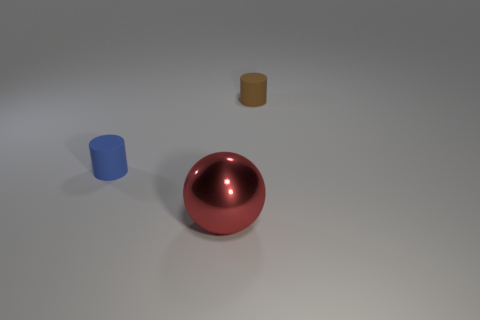Is there anything else that is the same size as the shiny ball?
Provide a short and direct response. No. Does the brown rubber cylinder have the same size as the metal sphere?
Make the answer very short. No. Are the tiny blue object that is behind the big metallic sphere and the cylinder right of the red shiny thing made of the same material?
Your response must be concise. Yes. Is there another matte thing of the same shape as the tiny brown matte thing?
Keep it short and to the point. Yes. What number of objects are big shiny balls in front of the brown matte cylinder or small blue rubber objects?
Give a very brief answer. 2. Are there more objects that are behind the big red metallic sphere than brown rubber things that are left of the tiny brown cylinder?
Your response must be concise. Yes. What number of rubber things are blue objects or large red objects?
Give a very brief answer. 1. Is the number of small brown rubber cylinders right of the large shiny sphere less than the number of objects that are in front of the small brown matte cylinder?
Offer a very short reply. Yes. How many objects are cylinders or large things that are to the right of the tiny blue thing?
Keep it short and to the point. 3. Do the red sphere and the tiny blue thing have the same material?
Keep it short and to the point. No. 